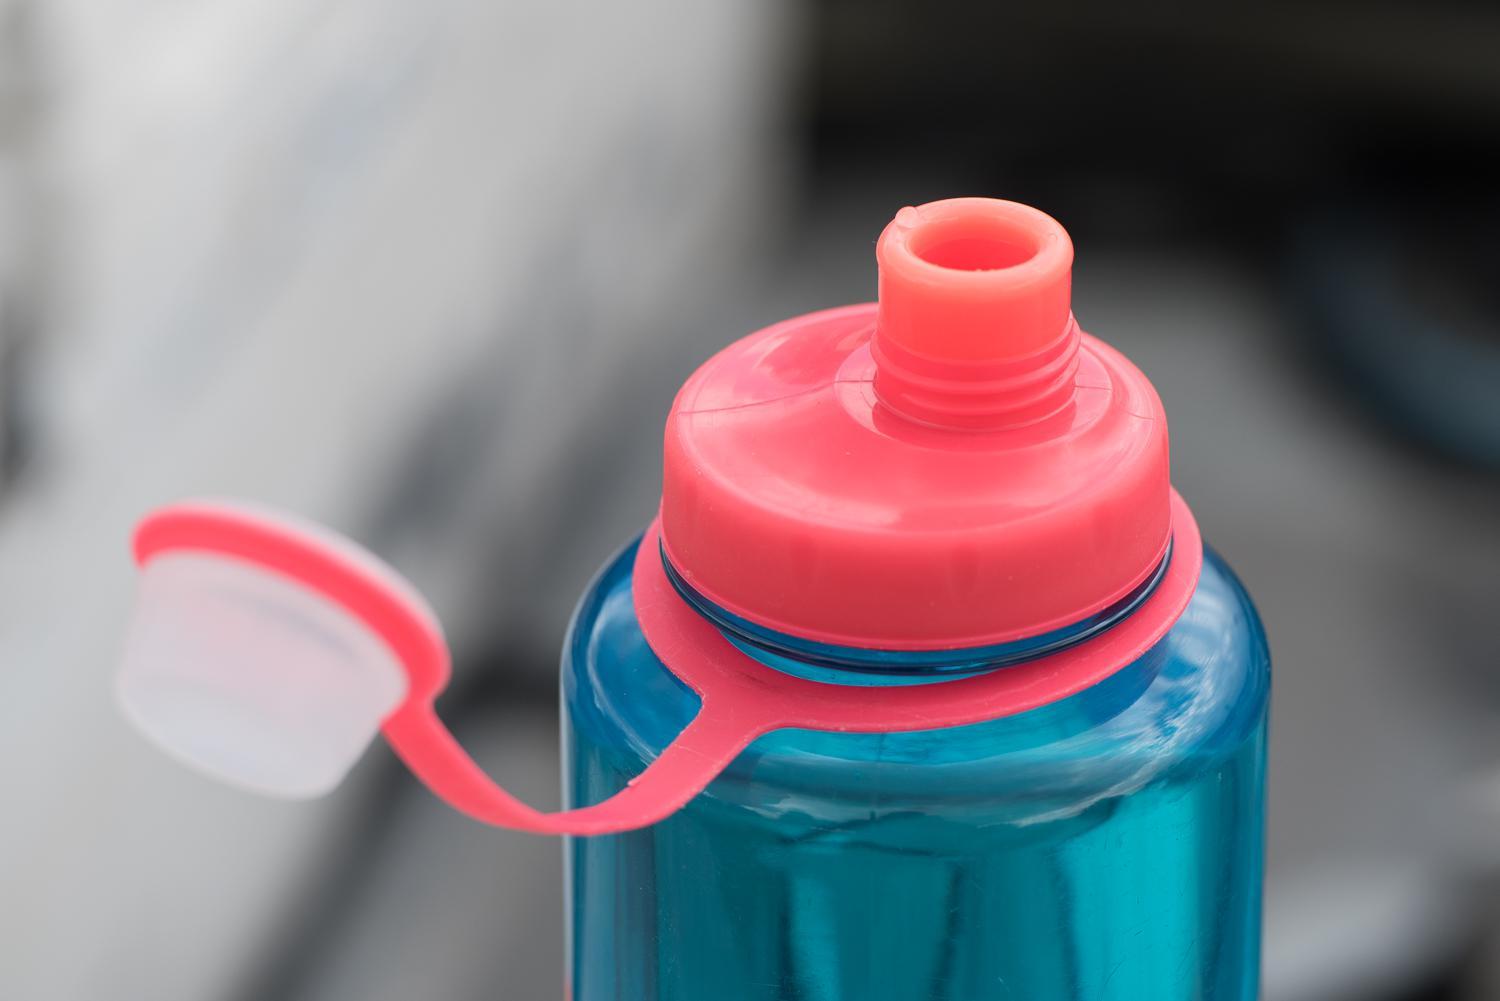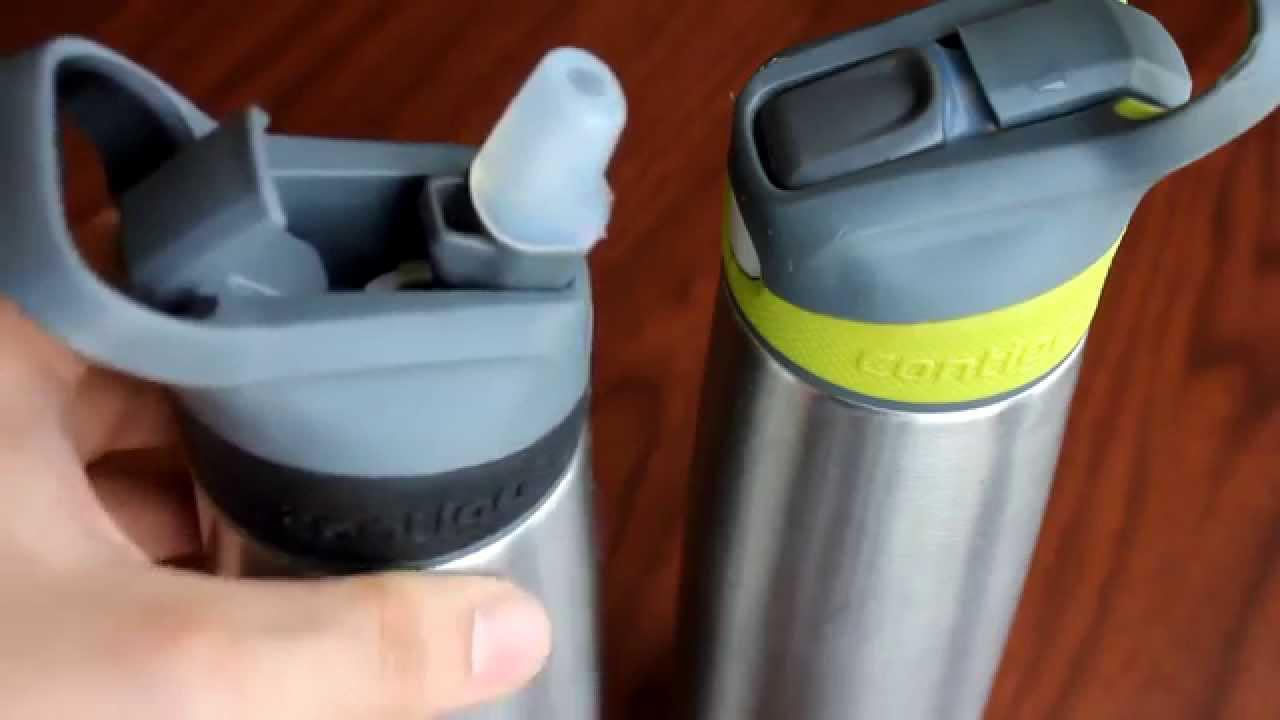The first image is the image on the left, the second image is the image on the right. For the images shown, is this caption "There are three water bottles in total." true? Answer yes or no. Yes. The first image is the image on the left, the second image is the image on the right. Analyze the images presented: Is the assertion "Two bottles are closed." valid? Answer yes or no. No. 